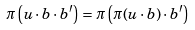<formula> <loc_0><loc_0><loc_500><loc_500>\pi \left ( u \cdot b \cdot b ^ { \prime } \right ) = \pi \left ( \pi ( u \cdot b ) \cdot b ^ { \prime } \right )</formula> 